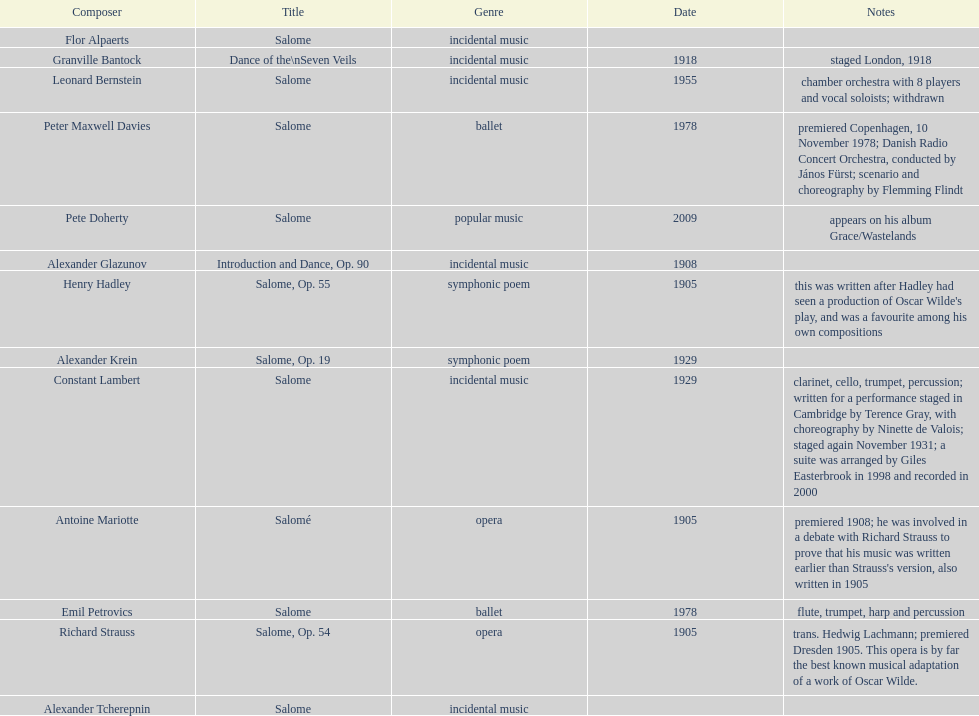Parse the table in full. {'header': ['Composer', 'Title', 'Genre', 'Date', 'Notes'], 'rows': [['Flor Alpaerts', 'Salome', 'incidental\xa0music', '', ''], ['Granville Bantock', 'Dance of the\\nSeven Veils', 'incidental music', '1918', 'staged London, 1918'], ['Leonard Bernstein', 'Salome', 'incidental music', '1955', 'chamber orchestra with 8 players and vocal soloists; withdrawn'], ['Peter\xa0Maxwell\xa0Davies', 'Salome', 'ballet', '1978', 'premiered Copenhagen, 10 November 1978; Danish Radio Concert Orchestra, conducted by János Fürst; scenario and choreography by Flemming Flindt'], ['Pete Doherty', 'Salome', 'popular music', '2009', 'appears on his album Grace/Wastelands'], ['Alexander Glazunov', 'Introduction and Dance, Op. 90', 'incidental music', '1908', ''], ['Henry Hadley', 'Salome, Op. 55', 'symphonic poem', '1905', "this was written after Hadley had seen a production of Oscar Wilde's play, and was a favourite among his own compositions"], ['Alexander Krein', 'Salome, Op. 19', 'symphonic poem', '1929', ''], ['Constant Lambert', 'Salome', 'incidental music', '1929', 'clarinet, cello, trumpet, percussion; written for a performance staged in Cambridge by Terence Gray, with choreography by Ninette de Valois; staged again November 1931; a suite was arranged by Giles Easterbrook in 1998 and recorded in 2000'], ['Antoine Mariotte', 'Salomé', 'opera', '1905', "premiered 1908; he was involved in a debate with Richard Strauss to prove that his music was written earlier than Strauss's version, also written in 1905"], ['Emil Petrovics', 'Salome', 'ballet', '1978', 'flute, trumpet, harp and percussion'], ['Richard Strauss', 'Salome, Op. 54', 'opera', '1905', 'trans. Hedwig Lachmann; premiered Dresden 1905. This opera is by far the best known musical adaptation of a work of Oscar Wilde.'], ['Alexander\xa0Tcherepnin', 'Salome', 'incidental music', '', '']]} What is the difference in years of granville bantock's work compared to pete dohert? 91. 